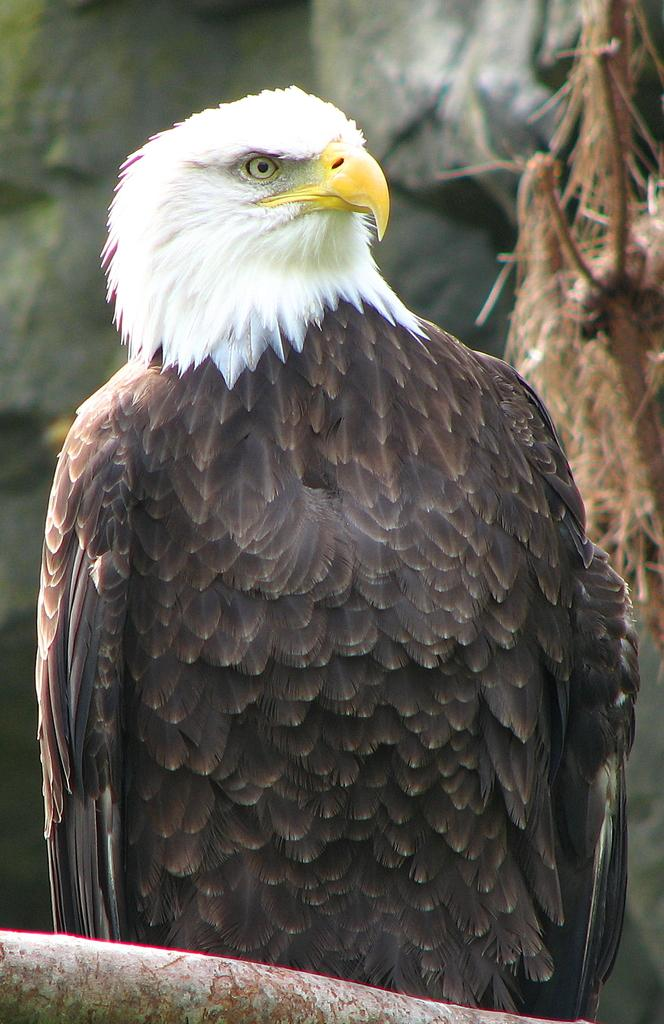What type of animal is in the image? There is a bird in the image. Can you describe the bird's coloring? The bird is white and black in color. What is the bird perched on in the image? The bird is perched on a tree branch in the image. What can be seen in the background of the image? There are green trees in the background of the image. What type of plastic material is draped over the bird in the image? There is no plastic material present in the image; it features a bird perched on a tree branch. What color is the linen used to cover the bird's nest in the image? There is no linen or bird's nest present in the image. 